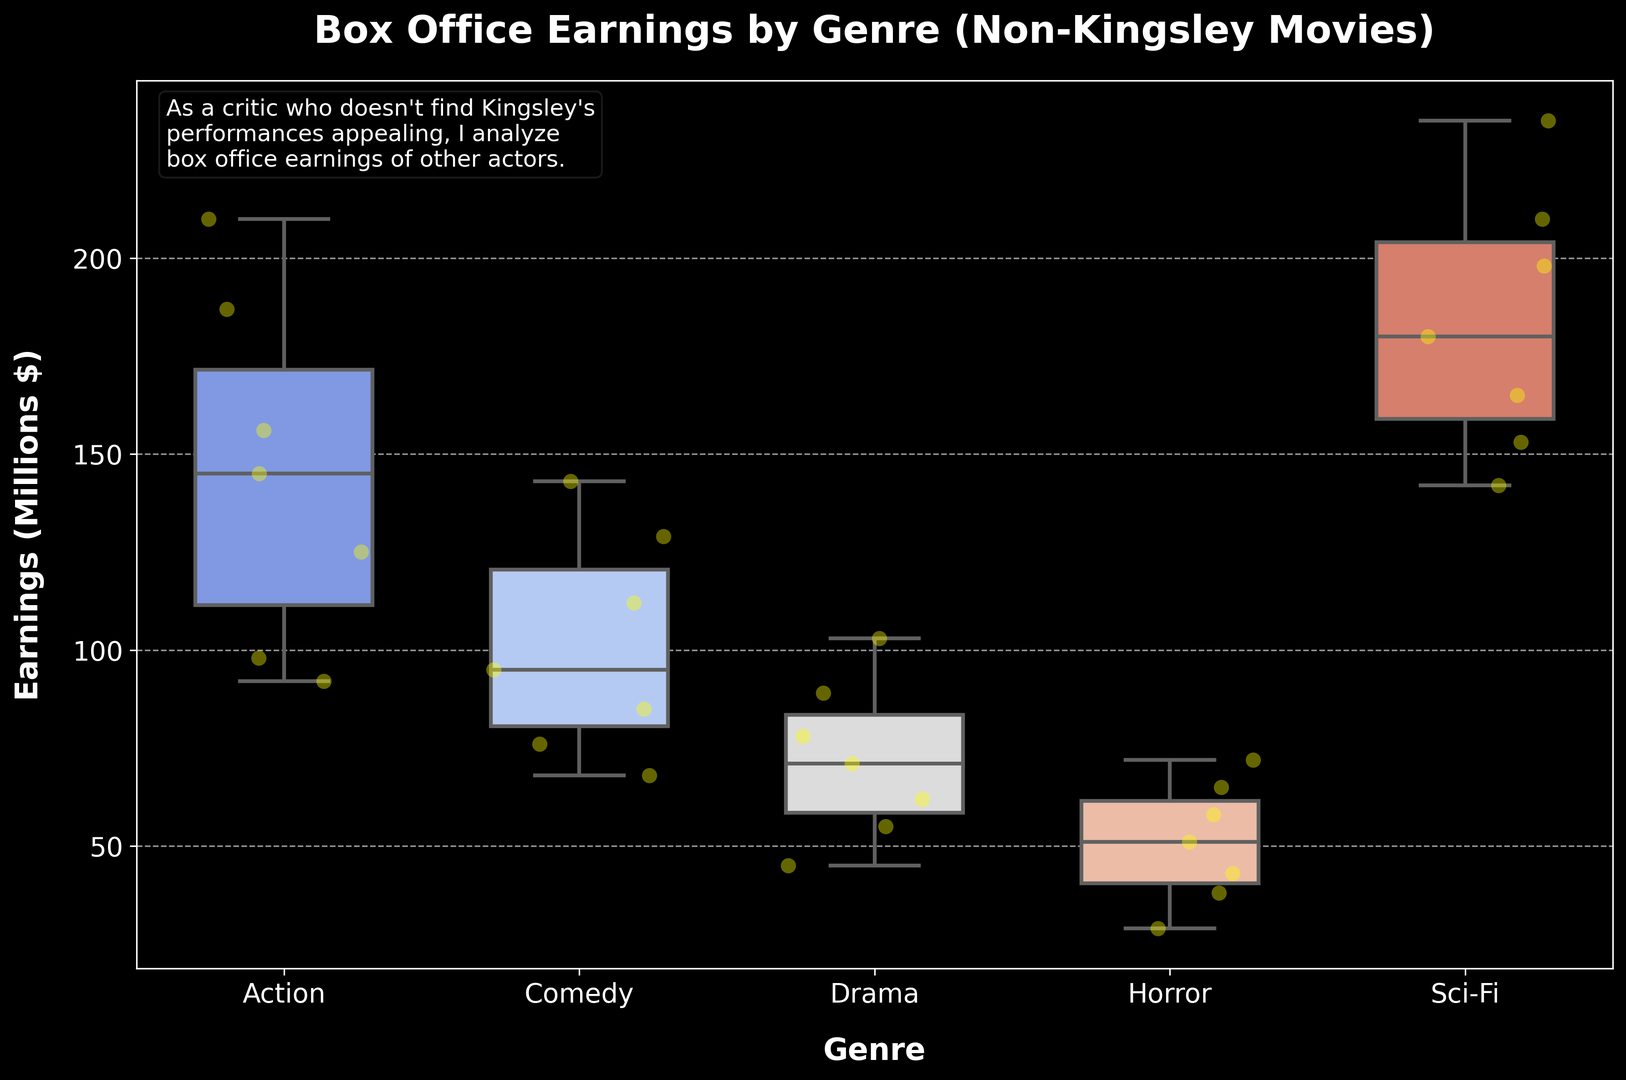Which genre has the highest median box office earnings? The median value is the middle value when the earnings are ordered. By inspecting the plot, the genre with the highest midpoint in the box's vertical stretch is Sci-Fi.
Answer: Sci-Fi What is the range of box office earnings for Comedy movies? The range is the difference between the maximum and minimum earnings. By looking at the Comedy box plot, the maximum is around 143 million, and the minimum is around 68 million. Thus, 143 - 68 = 75.
Answer: 75 million Which genre shows the widest spread in box office earnings? The spread is indicated by the length of the box and whiskers. Sci-Fi has the widest spread as its box and whiskers extend over a large range of earnings.
Answer: Sci-Fi Are the medians of Drama and Horror movies equal? By inspecting the central line in the boxes of both Drama and Horror, we can see if they are at the same level. Drama's median is around 71 million, while Horror's median is about 51 million. They are not equal.
Answer: No Which genre has the most consistent box office earnings (smallest interquartile range)? The interquartile range (IQR) is the length of the box. The shorter the box, the more consistent the earnings. Horror has the shortest box length, indicating it is the most consistent.
Answer: Horror How many genres have a median earning above 100 million? Count the number of boxes where the middle line (median) is above the 100 million mark. Both Action and Sci-Fi have medians above 100 million.
Answer: 2 genres What is the difference in median earnings between Action and Drama genres? The median for Action is approximately 145 million, and for Drama, it is 71 million. The difference is 145 - 71 = 74 million.
Answer: 74 million Which genres have their third quartile (top of the box) lower than 180 million? The third quartile marks the top edge of the box. Drama, Comedy, and Horror all have third quartiles below 180 million.
Answer: Drama, Comedy, Horror 